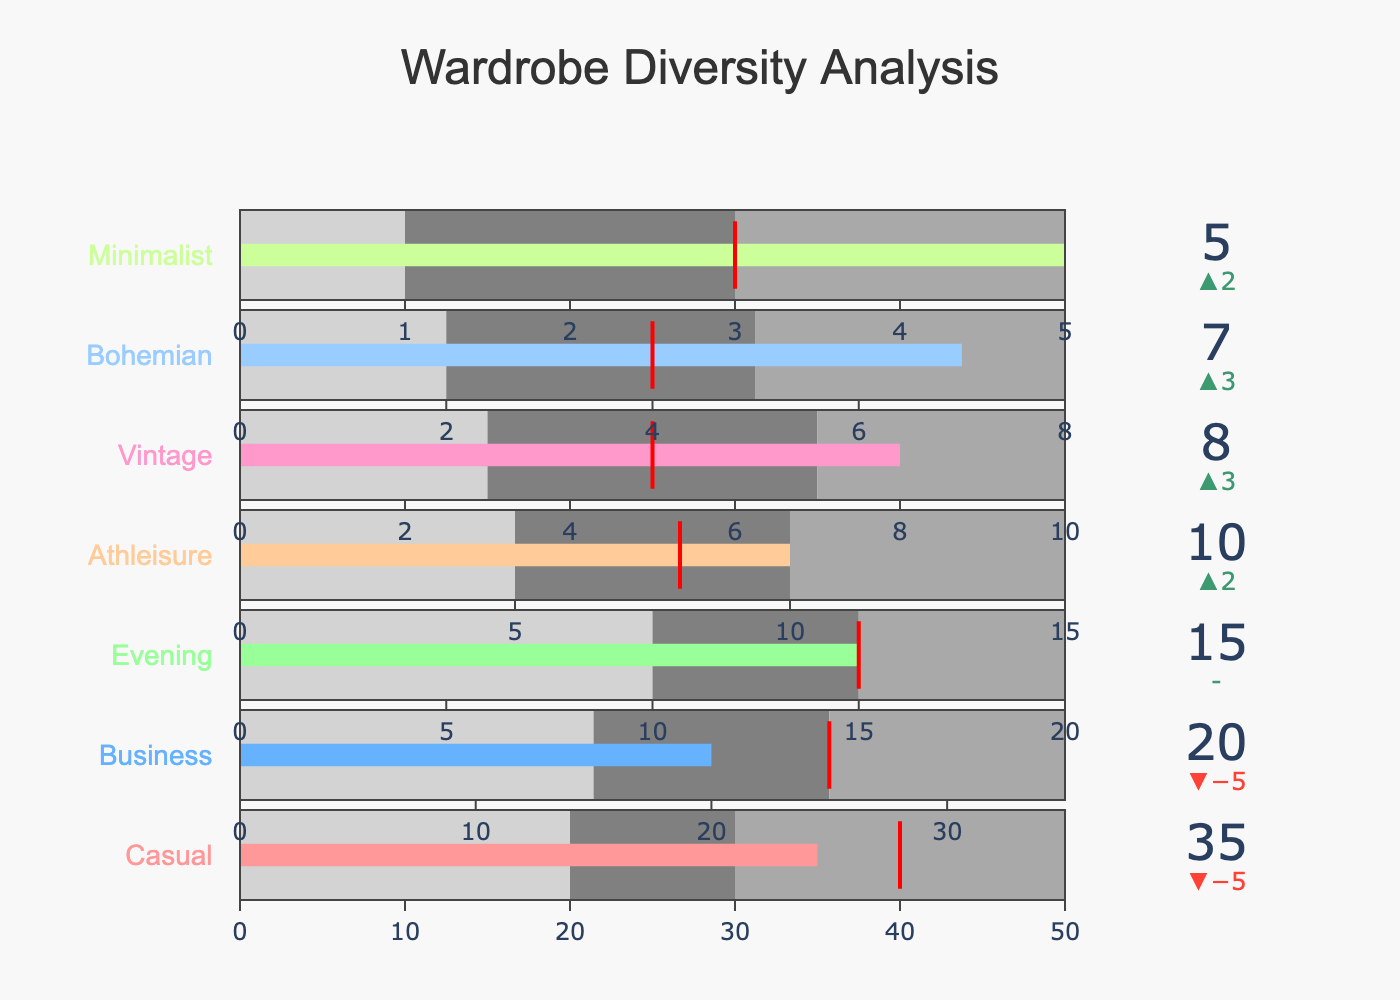What's the title of the figure? The title of the figure is displayed at the top and typically summarizes the overall content of the visual.
Answer: Wardrobe Diversity Analysis How many clothing styles are analyzed in the figure? Count the number of categories listed on the left side of the bullet chart to find the total number of different clothing styles.
Answer: 7 Which clothing style has the highest actual percentage? Compare the "Actual" values displayed in each bullet gauge to identify the highest one.
Answer: Casual Is the actual percentage for Athleisure above or below the target? Look at the bullet gauge for Athleisure, compare the actual value (10) against the target value (8) indicated by the red line.
Answer: Above Between Casual and Business styles, which one is closer to its target percentage? Compare the delta values which show the difference between actual and target for both Casual and Business styles. Casual has a delta of -5 and Business has a delta of -5. Business is closer as the absolute delta is smaller.
Answer: Business What is the average target percentage for all clothing styles? Add up all the target percentages and divide by the number of categories. (40 + 25 + 15 + 8 + 5 + 4 + 3) / 7 = 100 / 7
Answer: 14.29 Which clothing style exceeds its target by the greatest margin? Subtract the target percentage from the actual percentage for each clothing style and find the maximum positive difference. Athleisure exceeds its target by 2%.
Answer: Athleisure How does the actual percentage for Bohemian compare to its ideal range? Check where the Bohemian actual value of 7 falls within its provided ranges (2-8). It falls within the third range (5-8).
Answer: Within ideal range By how much does the actual percentage for Minimalist exceed its target? Subtract the target percentage (3) from the actual percentage (5). 5 - 3 = 2
Answer: 2 